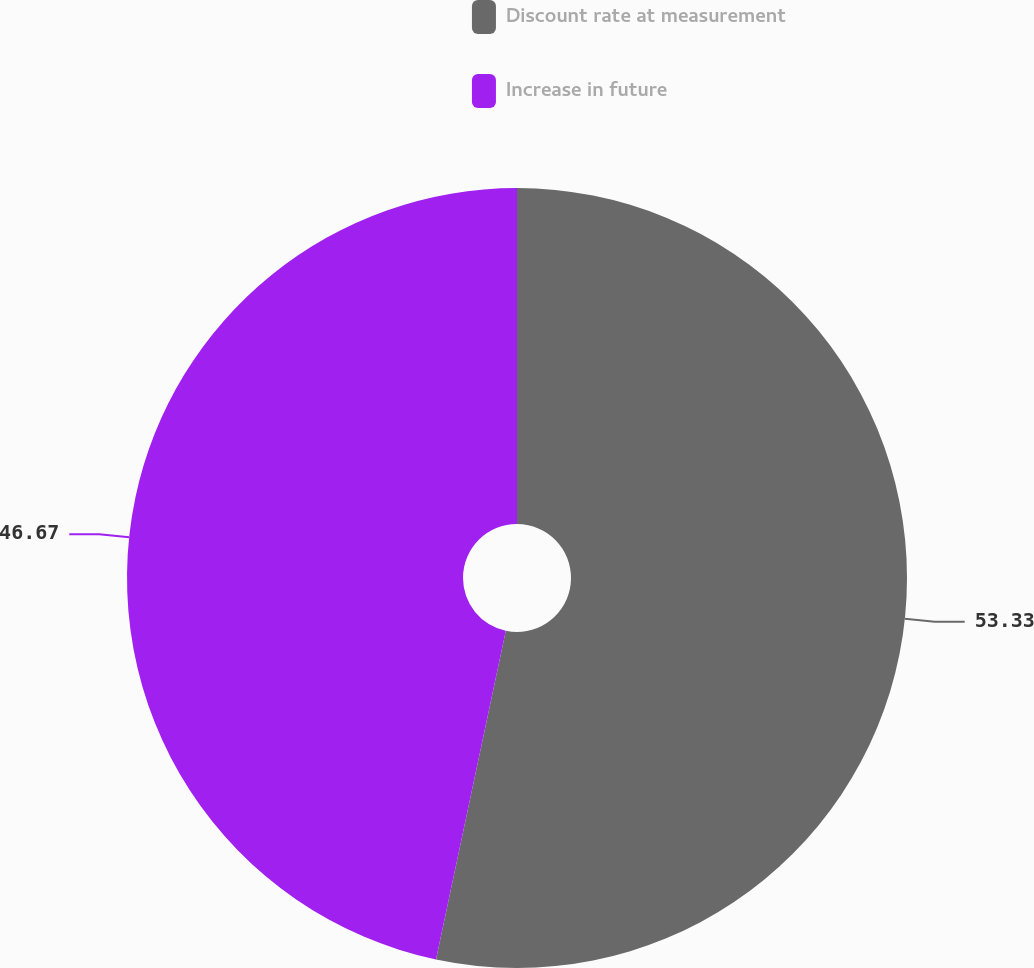Convert chart. <chart><loc_0><loc_0><loc_500><loc_500><pie_chart><fcel>Discount rate at measurement<fcel>Increase in future<nl><fcel>53.33%<fcel>46.67%<nl></chart> 